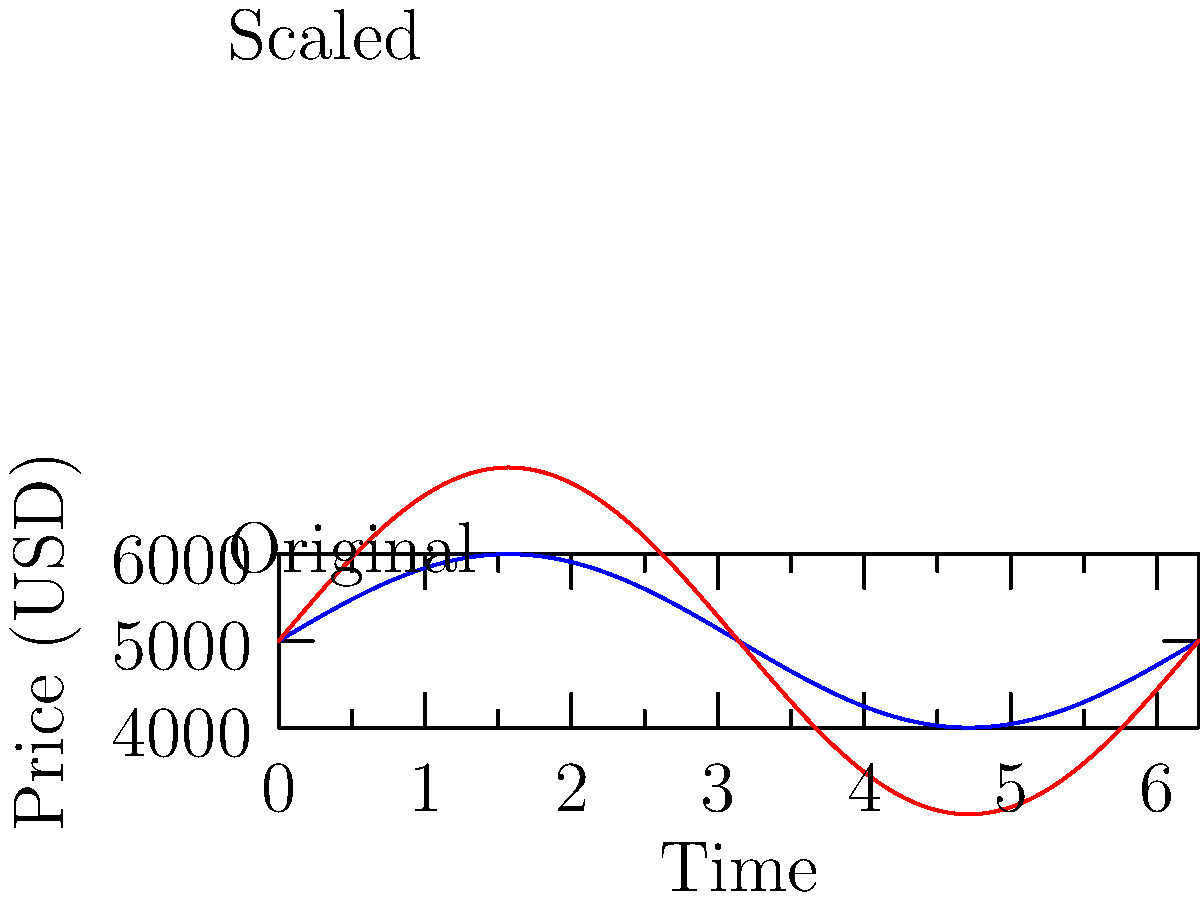A cryptocurrency's price fluctuations over time are represented by the blue curve. If the market experiences a bullish trend, doubling the price range while maintaining the same average price, which transformation would accurately represent this change?

A) $f(x) \rightarrow 2f(x)$
B) $f(x) \rightarrow f(x) + 5000$
C) $f(x) \rightarrow 2f(x) - 5000$
D) $f(x) \rightarrow \frac{1}{2}f(x) + 2500$ To solve this problem, let's approach it step-by-step:

1) The original function $f(x)$ represents the price fluctuations over time.

2) We need to double the price range. This means we need to multiply the function by 2.

3) However, we also need to maintain the same average price. The average price is represented by the midpoint of the oscillation.

4) In the original function, the midpoint is at $y = 5000$.

5) If we simply double the function ($2f(x)$), the midpoint would move to $y = 10000$.

6) To bring the midpoint back to 5000, we need to subtract 5000 after doubling.

7) Therefore, the correct transformation is: $f(x) \rightarrow 2f(x) - 5000$

8) This transformation doubles the amplitude of the oscillation (increasing the price range) while keeping the average price at 5000.

9) The red curve in the graph represents this transformed function, clearly showing the doubled range with the same midpoint.
Answer: C) $f(x) \rightarrow 2f(x) - 5000$ 